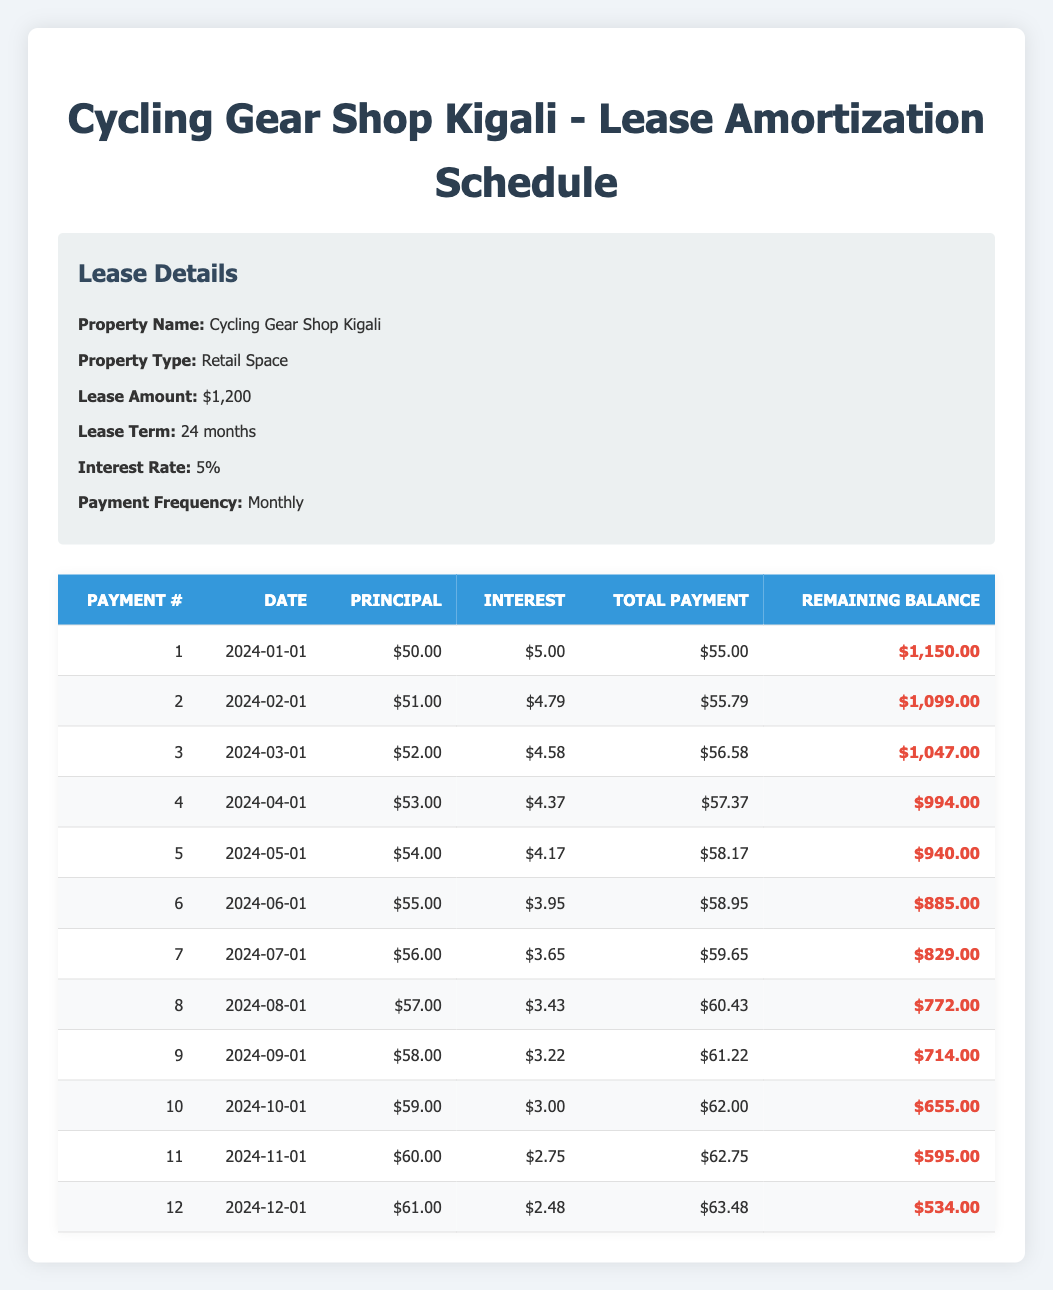What is the total payment for the first month? From the table, we can see that the total payment for the first month (payment number 1) is listed directly as 55.00.
Answer: 55.00 What is the remaining balance after the 6th payment? Looking at the table, the remaining balance after the 6th payment (payment number 6) is shown as 885.00.
Answer: 885.00 What is the difference between the principal payment for the 10th payment and the principal payment for the 5th payment? The principal payment for the 10th payment is 59.00, and the principal payment for the 5th payment is 54.00. The difference is 59.00 - 54.00 = 5.00.
Answer: 5.00 Is the interest payment for the 11th payment greater than the interest payment for the 9th payment? The interest payment for the 11th payment is 2.75, and the interest payment for the 9th payment is 3.22. Since 2.75 is not greater than 3.22, the answer is no.
Answer: No What is the total amount paid over the first six months? To find the total amount paid over the first six months, we sum the total payments for payments 1 through 6: 55.00 + 55.79 + 56.58 + 57.37 + 58.17 + 58.95 = 342.86.
Answer: 342.86 How much is the average principal payment over the first 12 payments? The sum of the principal payments from payment 1 to payment 12 is 50 + 51 + 52 + 53 + 54 + 55 + 56 + 57 + 58 + 59 + 60 + 61 = 674. To find the average, we divide by 12: 674 / 12 = 56.17.
Answer: 56.17 What will the remaining balance be after the 12th payment? After the 12th payment, the remaining balance is shown as 534.00 in the table.
Answer: 534.00 Which month has the highest total payment, based on the first 12 payments? The total payments from the table for the 12 months must be checked: the highest total payment is for the 12th payment, which is 63.48.
Answer: 63.48 Did the principal payment increase every month during the first 12 payments? Reviewing the principal payments for each of the first 12 payments shows that they steadily increased from 50 to 61, hence confirming it is true.
Answer: Yes 